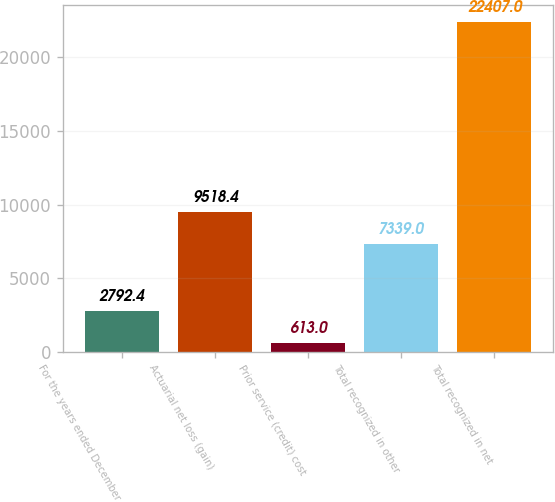Convert chart to OTSL. <chart><loc_0><loc_0><loc_500><loc_500><bar_chart><fcel>For the years ended December<fcel>Actuarial net loss (gain)<fcel>Prior service (credit) cost<fcel>Total recognized in other<fcel>Total recognized in net<nl><fcel>2792.4<fcel>9518.4<fcel>613<fcel>7339<fcel>22407<nl></chart> 